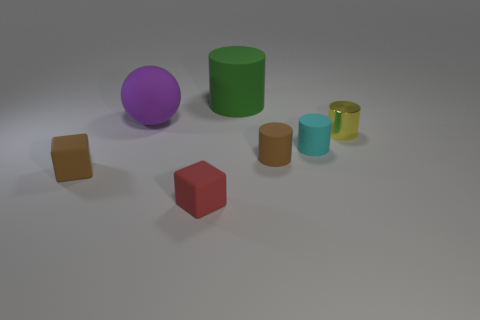Add 1 small yellow shiny cylinders. How many objects exist? 8 Subtract all spheres. How many objects are left? 6 Subtract all large gray shiny things. Subtract all cyan cylinders. How many objects are left? 6 Add 1 red blocks. How many red blocks are left? 2 Add 2 small yellow shiny spheres. How many small yellow shiny spheres exist? 2 Subtract 1 purple balls. How many objects are left? 6 